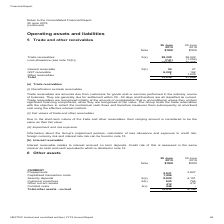According to Nextdc's financial document, How much was the security deposits in 2019? According to the financial document, 8,822 (in thousands). The relevant text states: "transaction costs 1,496 - Security deposits 6(a) 8,822 4,151 Customer incentives 6(b) 625 764 Other current assets 412 412 Contract costs 6(c) 446 - Total..." Also, How was customer incentives amortised? on a straight-line basis over the expected life of the contract. The document states: "lue of the incentive is capitalised and amortised on a straight-line basis over the expected life of the contract...." Also, How was contract costs amortised? over the expected customer life. The document states: "l be capitalised as a contract cost and amortised over the expected customer life...." Also, can you calculate: What was the percentage change in prepayments between 2018 and 2019? To answer this question, I need to perform calculations using the financial data. The calculation is: (2,631 - 3,827) / 3,827 , which equals -31.25 (percentage). This is based on the information: "CURRENT Prepayments 2,631 3,827 Capitalised transaction costs 1,496 - Security deposits 6(a) 8,822 4,151 Customer incentives CURRENT Prepayments 2,631 3,827 Capitalised transaction costs 1,496 - Secur..." The key data points involved are: 2,631, 3,827. Also, can you calculate: What was the percentage change in security deposits between 2018 and 2019? To answer this question, I need to perform calculations using the financial data. The calculation is: (8,822 - 4,151) / 4,151 , which equals 112.53 (percentage). This is based on the information: "action costs 1,496 - Security deposits 6(a) 8,822 4,151 Customer incentives 6(b) 625 764 Other current assets 412 412 Contract costs 6(c) 446 - Total other transaction costs 1,496 - Security deposits ..." The key data points involved are: 4,151, 8,822. Additionally, Which other assets (current) was the largest in 2018? According to the financial document, Security deposits. The relevant text states: "2,631 3,827 Capitalised transaction costs 1,496 - Security deposits 6(a) 8,822 4,151 Customer incentives 6(b) 625 764 Other current assets 412 412 Contract costs 6(c)..." 